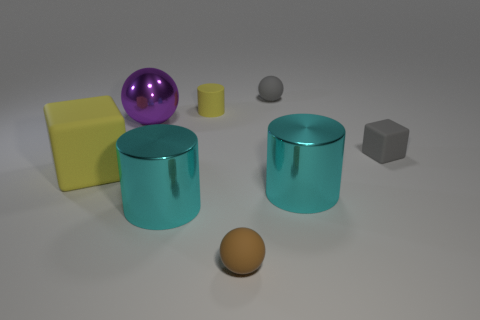Add 1 brown rubber balls. How many objects exist? 9 Subtract all big cyan cylinders. How many cylinders are left? 1 Subtract all blocks. How many objects are left? 6 Subtract 1 balls. How many balls are left? 2 Subtract all red spheres. How many yellow cylinders are left? 1 Subtract all large gray metal objects. Subtract all small rubber blocks. How many objects are left? 7 Add 2 tiny yellow matte cylinders. How many tiny yellow matte cylinders are left? 3 Add 7 gray rubber balls. How many gray rubber balls exist? 8 Subtract all yellow cylinders. How many cylinders are left? 2 Subtract 0 cyan cubes. How many objects are left? 8 